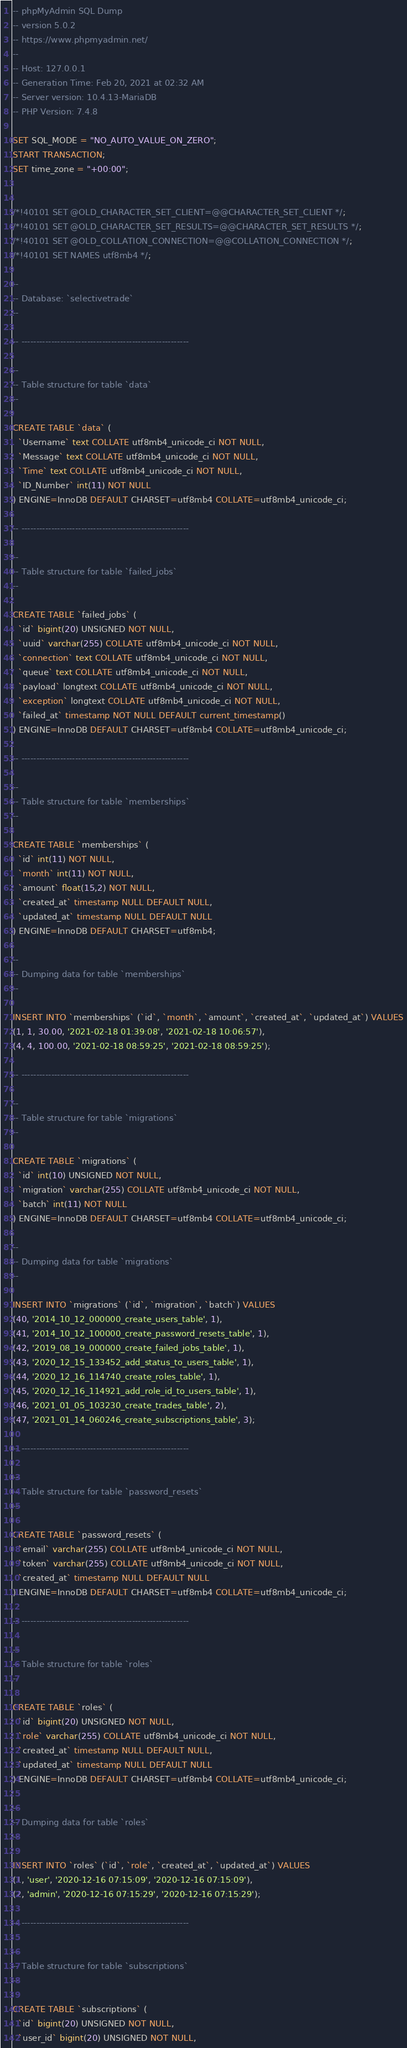<code> <loc_0><loc_0><loc_500><loc_500><_SQL_>-- phpMyAdmin SQL Dump
-- version 5.0.2
-- https://www.phpmyadmin.net/
--
-- Host: 127.0.0.1
-- Generation Time: Feb 20, 2021 at 02:32 AM
-- Server version: 10.4.13-MariaDB
-- PHP Version: 7.4.8

SET SQL_MODE = "NO_AUTO_VALUE_ON_ZERO";
START TRANSACTION;
SET time_zone = "+00:00";


/*!40101 SET @OLD_CHARACTER_SET_CLIENT=@@CHARACTER_SET_CLIENT */;
/*!40101 SET @OLD_CHARACTER_SET_RESULTS=@@CHARACTER_SET_RESULTS */;
/*!40101 SET @OLD_COLLATION_CONNECTION=@@COLLATION_CONNECTION */;
/*!40101 SET NAMES utf8mb4 */;

--
-- Database: `selectivetrade`
--

-- --------------------------------------------------------

--
-- Table structure for table `data`
--

CREATE TABLE `data` (
  `Username` text COLLATE utf8mb4_unicode_ci NOT NULL,
  `Message` text COLLATE utf8mb4_unicode_ci NOT NULL,
  `Time` text COLLATE utf8mb4_unicode_ci NOT NULL,
  `ID_Number` int(11) NOT NULL
) ENGINE=InnoDB DEFAULT CHARSET=utf8mb4 COLLATE=utf8mb4_unicode_ci;

-- --------------------------------------------------------

--
-- Table structure for table `failed_jobs`
--

CREATE TABLE `failed_jobs` (
  `id` bigint(20) UNSIGNED NOT NULL,
  `uuid` varchar(255) COLLATE utf8mb4_unicode_ci NOT NULL,
  `connection` text COLLATE utf8mb4_unicode_ci NOT NULL,
  `queue` text COLLATE utf8mb4_unicode_ci NOT NULL,
  `payload` longtext COLLATE utf8mb4_unicode_ci NOT NULL,
  `exception` longtext COLLATE utf8mb4_unicode_ci NOT NULL,
  `failed_at` timestamp NOT NULL DEFAULT current_timestamp()
) ENGINE=InnoDB DEFAULT CHARSET=utf8mb4 COLLATE=utf8mb4_unicode_ci;

-- --------------------------------------------------------

--
-- Table structure for table `memberships`
--

CREATE TABLE `memberships` (
  `id` int(11) NOT NULL,
  `month` int(11) NOT NULL,
  `amount` float(15,2) NOT NULL,
  `created_at` timestamp NULL DEFAULT NULL,
  `updated_at` timestamp NULL DEFAULT NULL
) ENGINE=InnoDB DEFAULT CHARSET=utf8mb4;

--
-- Dumping data for table `memberships`
--

INSERT INTO `memberships` (`id`, `month`, `amount`, `created_at`, `updated_at`) VALUES
(1, 1, 30.00, '2021-02-18 01:39:08', '2021-02-18 10:06:57'),
(4, 4, 100.00, '2021-02-18 08:59:25', '2021-02-18 08:59:25');

-- --------------------------------------------------------

--
-- Table structure for table `migrations`
--

CREATE TABLE `migrations` (
  `id` int(10) UNSIGNED NOT NULL,
  `migration` varchar(255) COLLATE utf8mb4_unicode_ci NOT NULL,
  `batch` int(11) NOT NULL
) ENGINE=InnoDB DEFAULT CHARSET=utf8mb4 COLLATE=utf8mb4_unicode_ci;

--
-- Dumping data for table `migrations`
--

INSERT INTO `migrations` (`id`, `migration`, `batch`) VALUES
(40, '2014_10_12_000000_create_users_table', 1),
(41, '2014_10_12_100000_create_password_resets_table', 1),
(42, '2019_08_19_000000_create_failed_jobs_table', 1),
(43, '2020_12_15_133452_add_status_to_users_table', 1),
(44, '2020_12_16_114740_create_roles_table', 1),
(45, '2020_12_16_114921_add_role_id_to_users_table', 1),
(46, '2021_01_05_103230_create_trades_table', 2),
(47, '2021_01_14_060246_create_subscriptions_table', 3);

-- --------------------------------------------------------

--
-- Table structure for table `password_resets`
--

CREATE TABLE `password_resets` (
  `email` varchar(255) COLLATE utf8mb4_unicode_ci NOT NULL,
  `token` varchar(255) COLLATE utf8mb4_unicode_ci NOT NULL,
  `created_at` timestamp NULL DEFAULT NULL
) ENGINE=InnoDB DEFAULT CHARSET=utf8mb4 COLLATE=utf8mb4_unicode_ci;

-- --------------------------------------------------------

--
-- Table structure for table `roles`
--

CREATE TABLE `roles` (
  `id` bigint(20) UNSIGNED NOT NULL,
  `role` varchar(255) COLLATE utf8mb4_unicode_ci NOT NULL,
  `created_at` timestamp NULL DEFAULT NULL,
  `updated_at` timestamp NULL DEFAULT NULL
) ENGINE=InnoDB DEFAULT CHARSET=utf8mb4 COLLATE=utf8mb4_unicode_ci;

--
-- Dumping data for table `roles`
--

INSERT INTO `roles` (`id`, `role`, `created_at`, `updated_at`) VALUES
(1, 'user', '2020-12-16 07:15:09', '2020-12-16 07:15:09'),
(2, 'admin', '2020-12-16 07:15:29', '2020-12-16 07:15:29');

-- --------------------------------------------------------

--
-- Table structure for table `subscriptions`
--

CREATE TABLE `subscriptions` (
  `id` bigint(20) UNSIGNED NOT NULL,
  `user_id` bigint(20) UNSIGNED NOT NULL,</code> 